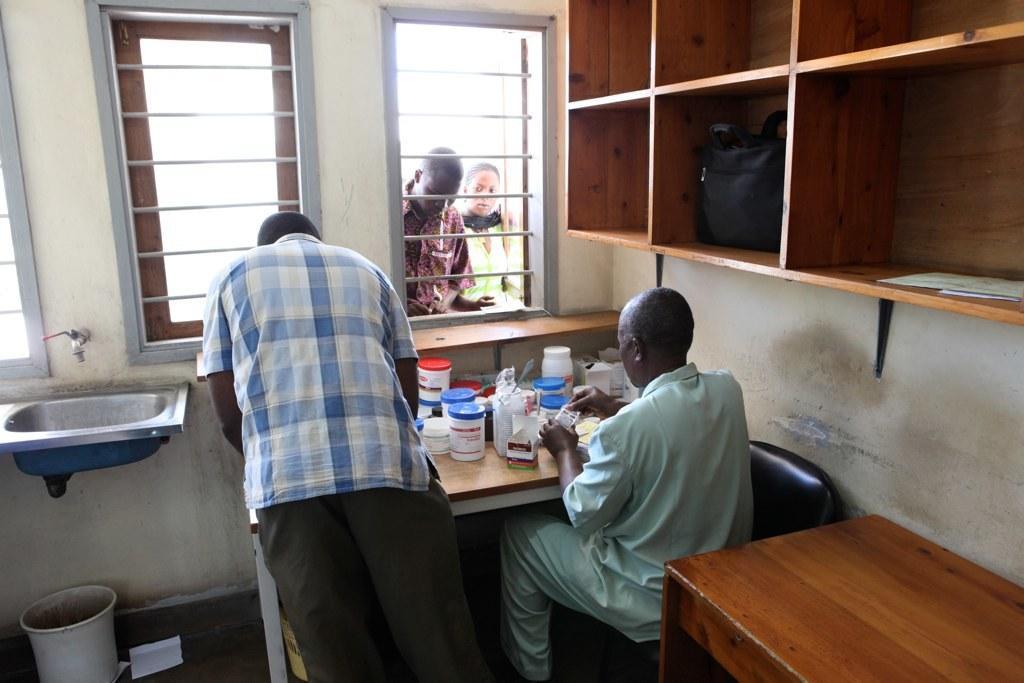Please provide a concise description of this image. In this image I can see four people. To the right there is a cupboard and a bag inside the cupboard. To the left there is a sink and on the table there are some containers. 